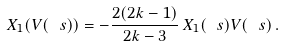Convert formula to latex. <formula><loc_0><loc_0><loc_500><loc_500>X _ { 1 } ( V ( \ s ) ) = - \frac { 2 ( 2 k - 1 ) } { 2 k - 3 } \, X _ { 1 } ( \ s ) V ( \ s ) \, .</formula> 